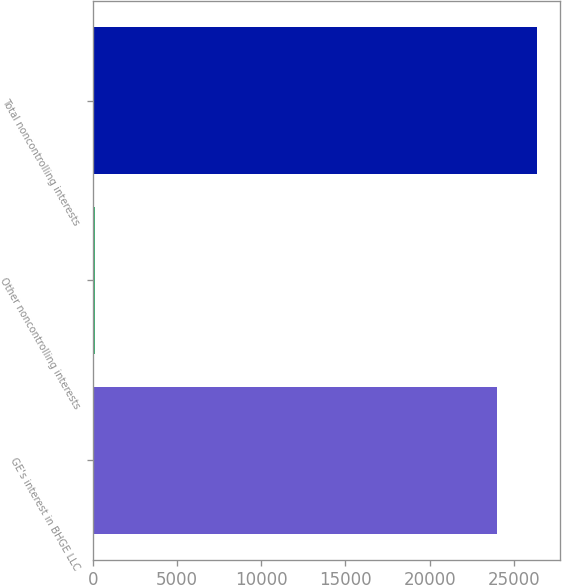Convert chart to OTSL. <chart><loc_0><loc_0><loc_500><loc_500><bar_chart><fcel>GE's interest in BHGE LLC<fcel>Other noncontrolling interests<fcel>Total noncontrolling interests<nl><fcel>23993<fcel>140<fcel>26392.3<nl></chart> 